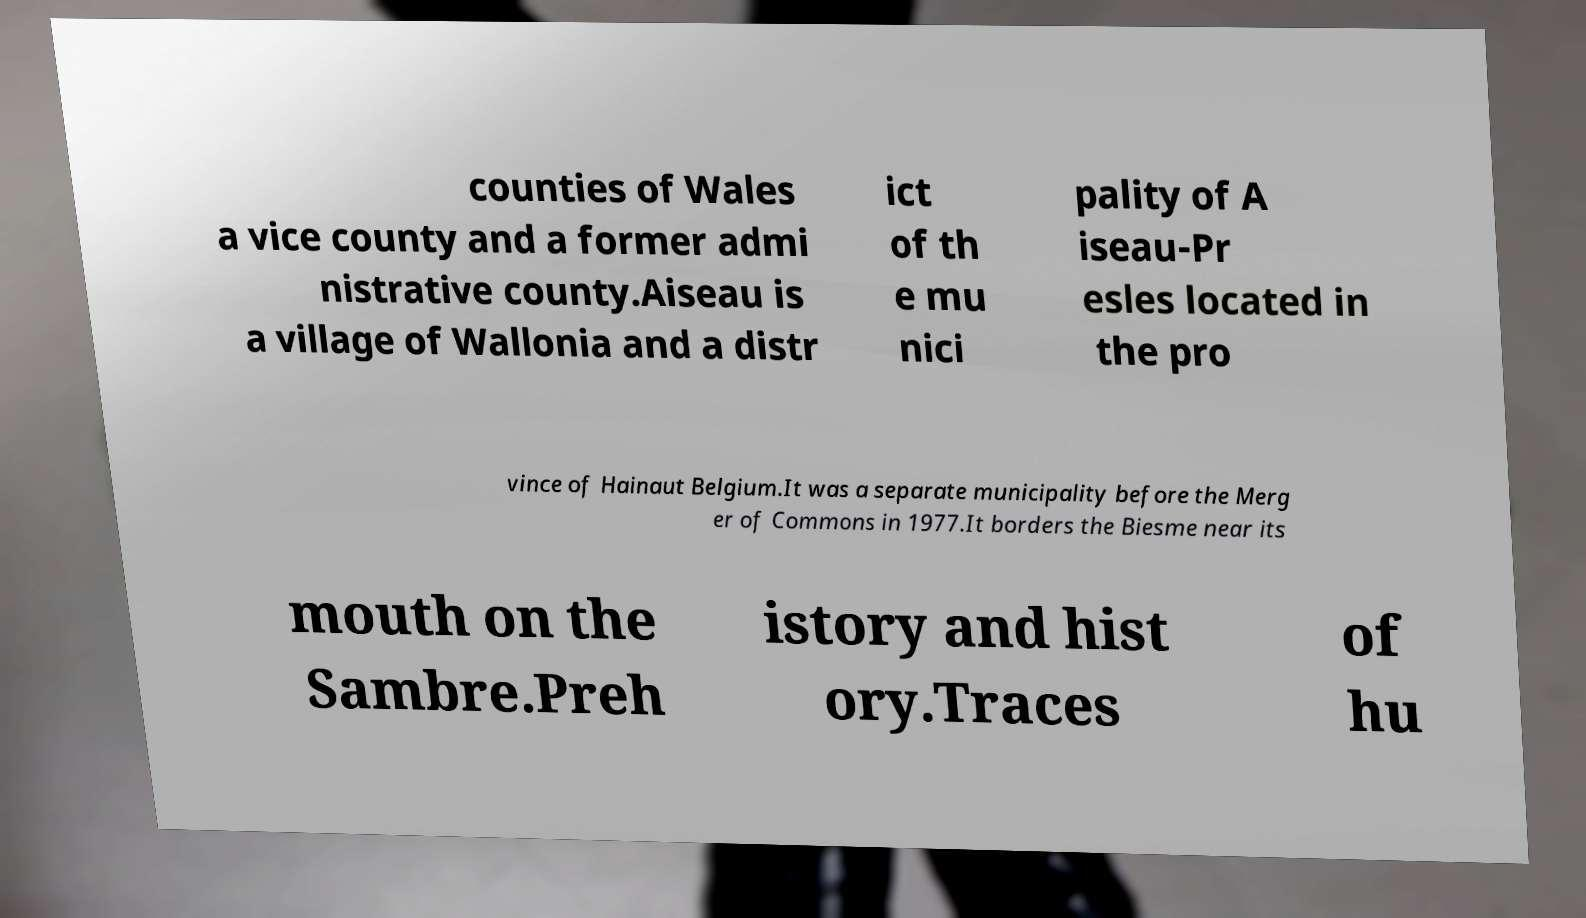Can you read and provide the text displayed in the image?This photo seems to have some interesting text. Can you extract and type it out for me? counties of Wales a vice county and a former admi nistrative county.Aiseau is a village of Wallonia and a distr ict of th e mu nici pality of A iseau-Pr esles located in the pro vince of Hainaut Belgium.It was a separate municipality before the Merg er of Commons in 1977.It borders the Biesme near its mouth on the Sambre.Preh istory and hist ory.Traces of hu 